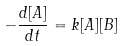<formula> <loc_0><loc_0><loc_500><loc_500>- \frac { d [ A ] } { d t } = k [ A ] [ B ]</formula> 